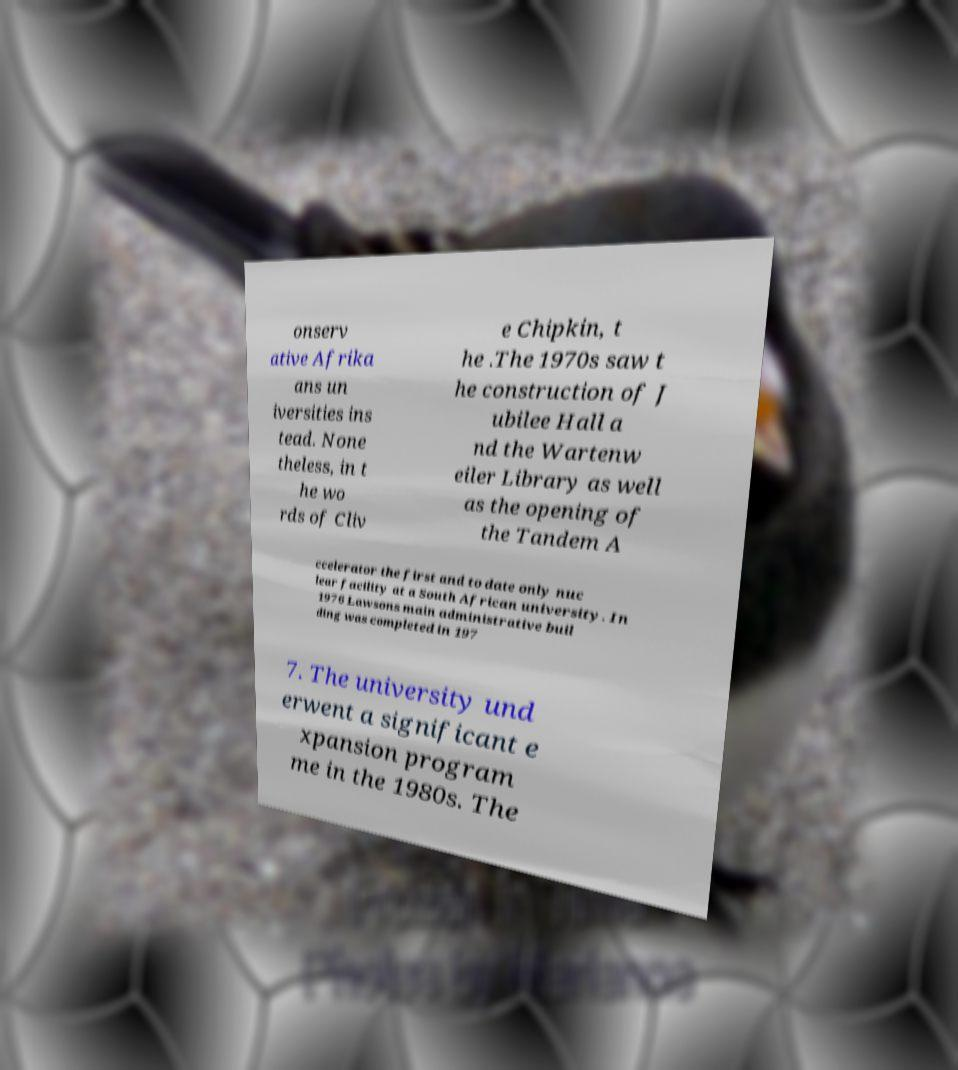Please read and relay the text visible in this image. What does it say? onserv ative Afrika ans un iversities ins tead. None theless, in t he wo rds of Cliv e Chipkin, t he .The 1970s saw t he construction of J ubilee Hall a nd the Wartenw eiler Library as well as the opening of the Tandem A ccelerator the first and to date only nuc lear facility at a South African university. In 1976 Lawsons main administrative buil ding was completed in 197 7. The university und erwent a significant e xpansion program me in the 1980s. The 